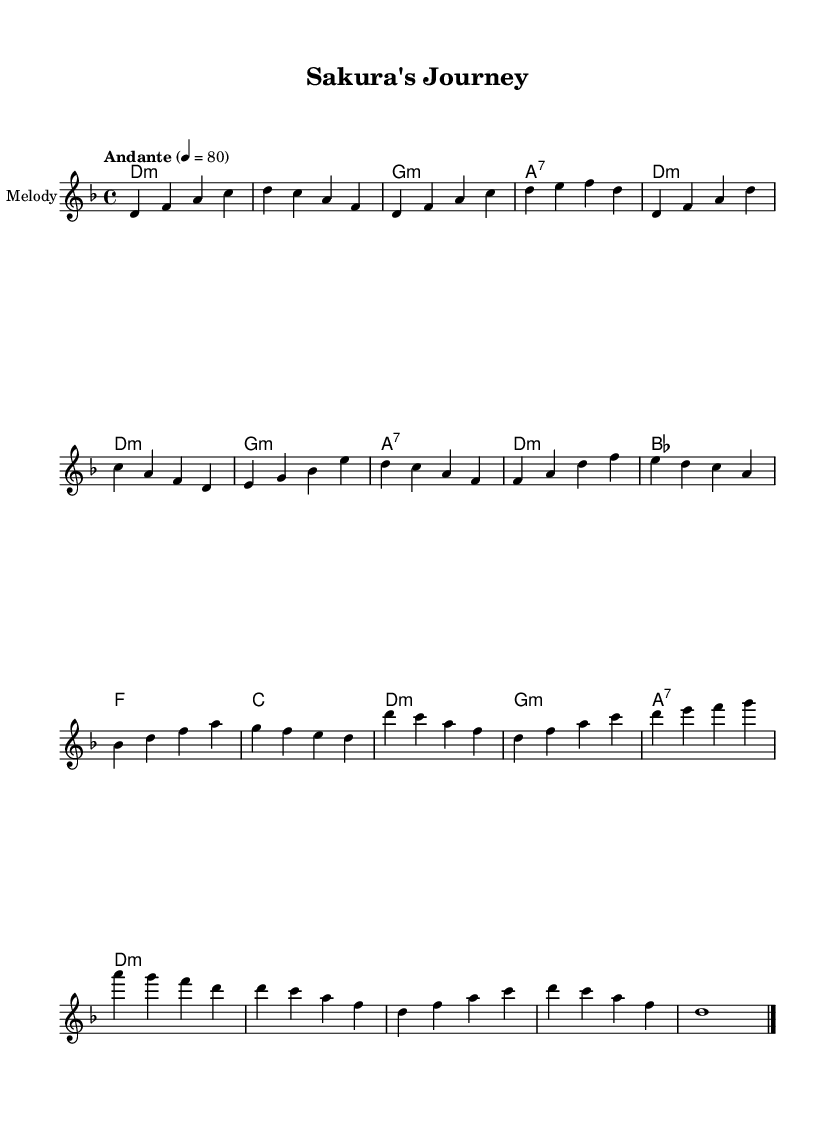What is the key signature of this music? The key signature indicates the piece is in D minor, which has one flat. This is noted at the beginning of the score.
Answer: D minor What is the time signature of the piece? The time signature shown at the start of the score is 4/4, which means there are four beats in each measure.
Answer: 4/4 What is the indicated tempo for the piece? The tempo marking is "Andante" with a metronome marking of 80, which suggests a moderate speed for the piece.
Answer: Andante, 80 What type of instrument is specified for the melody? The instrument name mentioned in the score for the melody is "shakuhachi," which is a traditional Japanese bamboo flute.
Answer: shakuhachi How many measures are in the introduction section? By examining the music, it can be counted that there are four measures in the introduction before the verse begins.
Answer: 4 What is the harmonic progression for the chorus? The harmonic progression listed for the chorus is D minor, E minor, B flat, and A7, indicating a sequence of chords used during that section.
Answer: D minor, E minor, B flat, A7 What is the last note of the piece? The last note of the music score in the outro is a D, which is sustained to conclude the piece.
Answer: D 